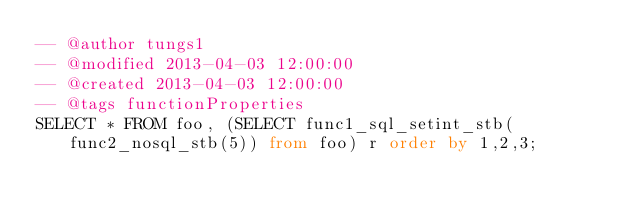<code> <loc_0><loc_0><loc_500><loc_500><_SQL_>-- @author tungs1
-- @modified 2013-04-03 12:00:00
-- @created 2013-04-03 12:00:00
-- @tags functionProperties 
SELECT * FROM foo, (SELECT func1_sql_setint_stb(func2_nosql_stb(5)) from foo) r order by 1,2,3; 
</code> 